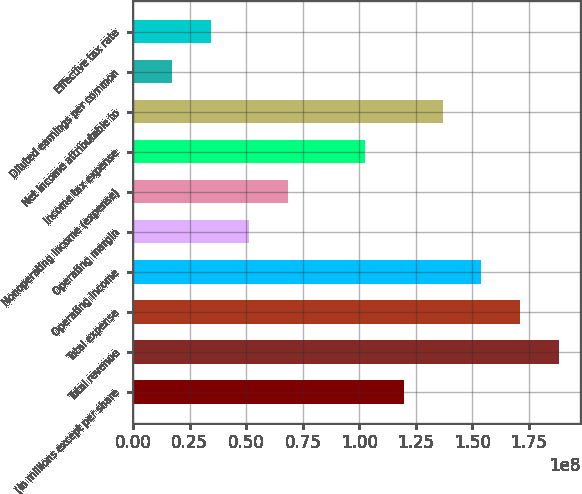Convert chart to OTSL. <chart><loc_0><loc_0><loc_500><loc_500><bar_chart><fcel>(in millions except per share<fcel>Total revenue<fcel>Total expense<fcel>Operating income<fcel>Operating margin<fcel>Nonoperating income (expense)<fcel>Income tax expense<fcel>Net income attributable to<fcel>Diluted earnings per common<fcel>Effective tax rate<nl><fcel>1.19779e+08<fcel>1.88223e+08<fcel>1.71112e+08<fcel>1.54001e+08<fcel>5.13337e+07<fcel>6.84449e+07<fcel>1.02667e+08<fcel>1.3689e+08<fcel>1.71112e+07<fcel>3.42225e+07<nl></chart> 